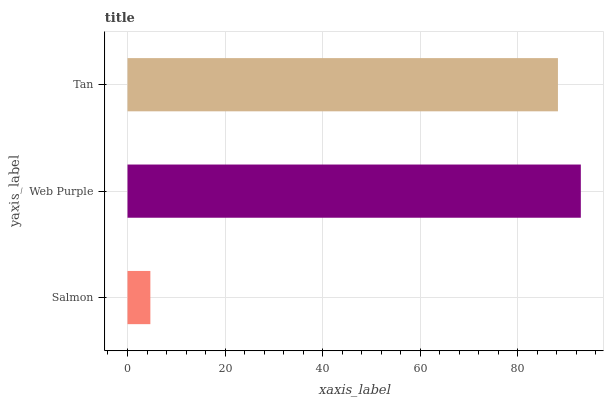Is Salmon the minimum?
Answer yes or no. Yes. Is Web Purple the maximum?
Answer yes or no. Yes. Is Tan the minimum?
Answer yes or no. No. Is Tan the maximum?
Answer yes or no. No. Is Web Purple greater than Tan?
Answer yes or no. Yes. Is Tan less than Web Purple?
Answer yes or no. Yes. Is Tan greater than Web Purple?
Answer yes or no. No. Is Web Purple less than Tan?
Answer yes or no. No. Is Tan the high median?
Answer yes or no. Yes. Is Tan the low median?
Answer yes or no. Yes. Is Salmon the high median?
Answer yes or no. No. Is Web Purple the low median?
Answer yes or no. No. 